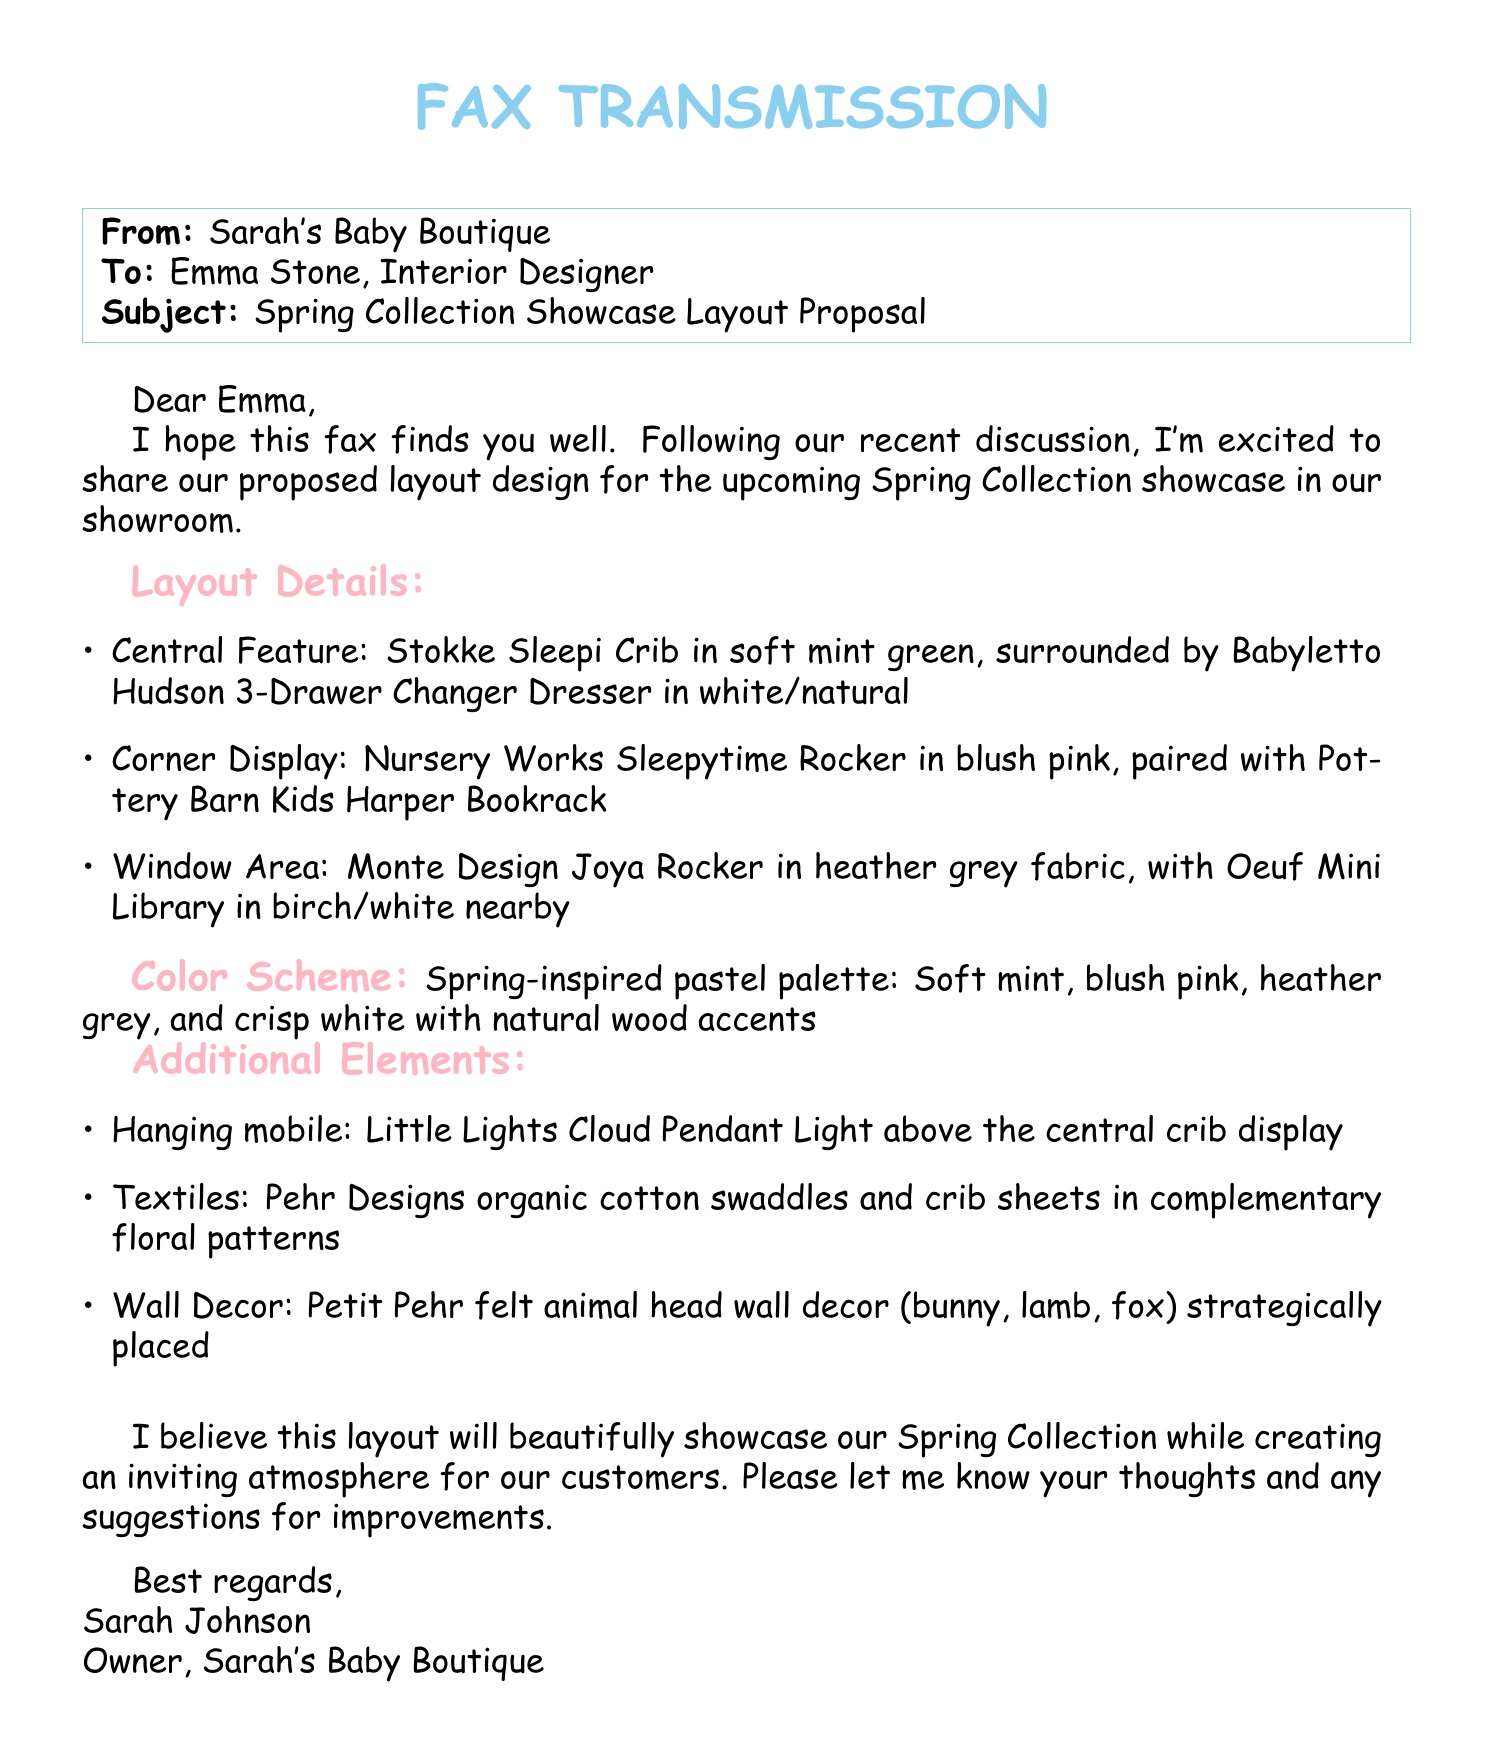what is the name of the central feature in the layout? The central feature is the Stokke Sleepi Crib in soft mint green.
Answer: Stokke Sleepi Crib what color is the Babyletto Hudson 3-Drawer Changer Dresser? It is described as white/natural in the document.
Answer: white/natural what additional element is above the central crib display? A hanging mobile is mentioned, specifically the Little Lights Cloud Pendant Light.
Answer: Little Lights Cloud Pendant Light how many colors are specified in the spring-inspired pastel palette? The document lists four colors in the color scheme.
Answer: four which rocking chair is placed in the corner display? The Nursery Works Sleepytime Rocker is the one mentioned for the corner display.
Answer: Nursery Works Sleepytime Rocker what textile brand is mentioned for organic cotton swaddles? The brand Pehr Designs is stated in the document.
Answer: Pehr Designs who is the sender of the fax? The sender is identified as Sarah Johnson.
Answer: Sarah Johnson what is the primary purpose of this fax? The primary purpose is to propose a layout design for the Spring Collection showcase.
Answer: propose a layout design which wall decor items are included in the additional elements? The document lists Petit Pehr felt animal head wall decor (bunny, lamb, fox).
Answer: bunny, lamb, fox 